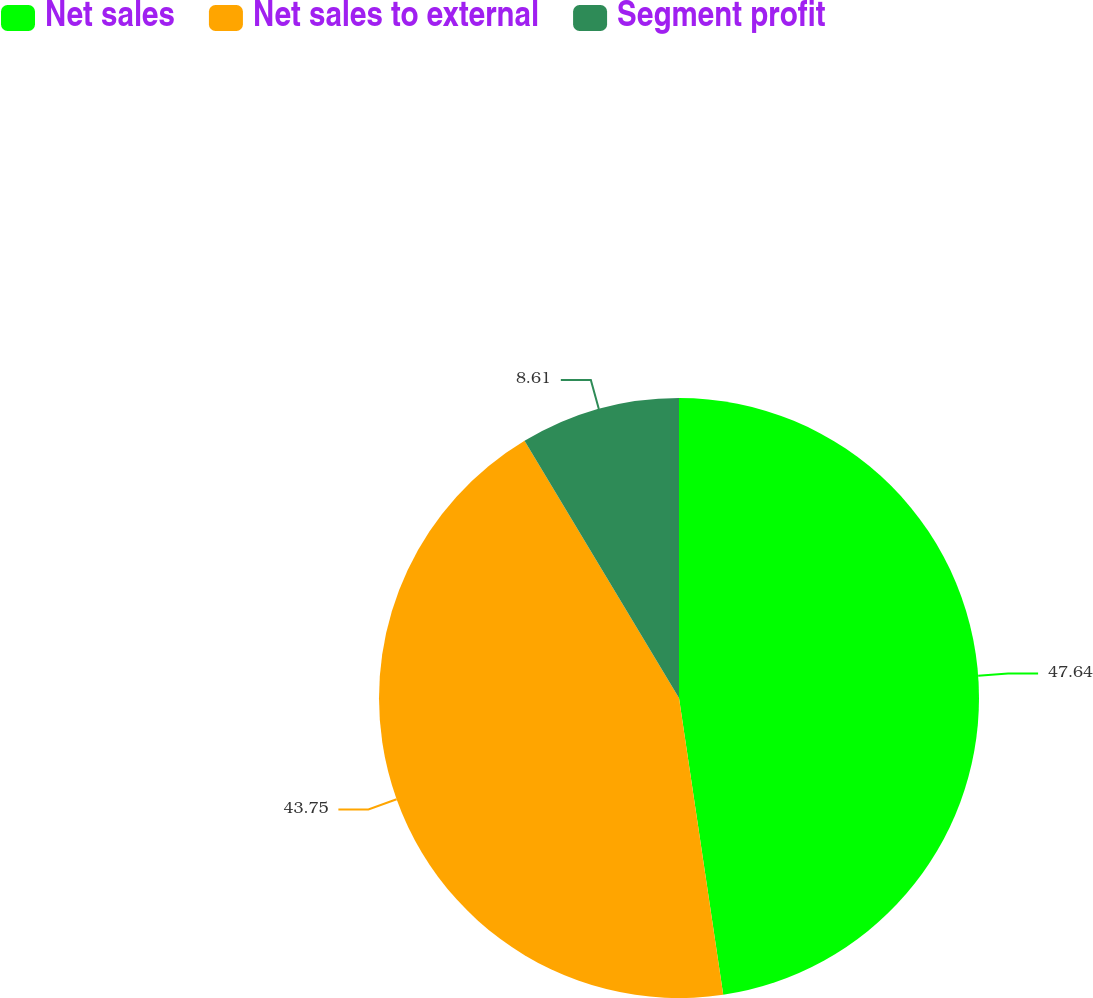Convert chart. <chart><loc_0><loc_0><loc_500><loc_500><pie_chart><fcel>Net sales<fcel>Net sales to external<fcel>Segment profit<nl><fcel>47.65%<fcel>43.75%<fcel>8.61%<nl></chart> 